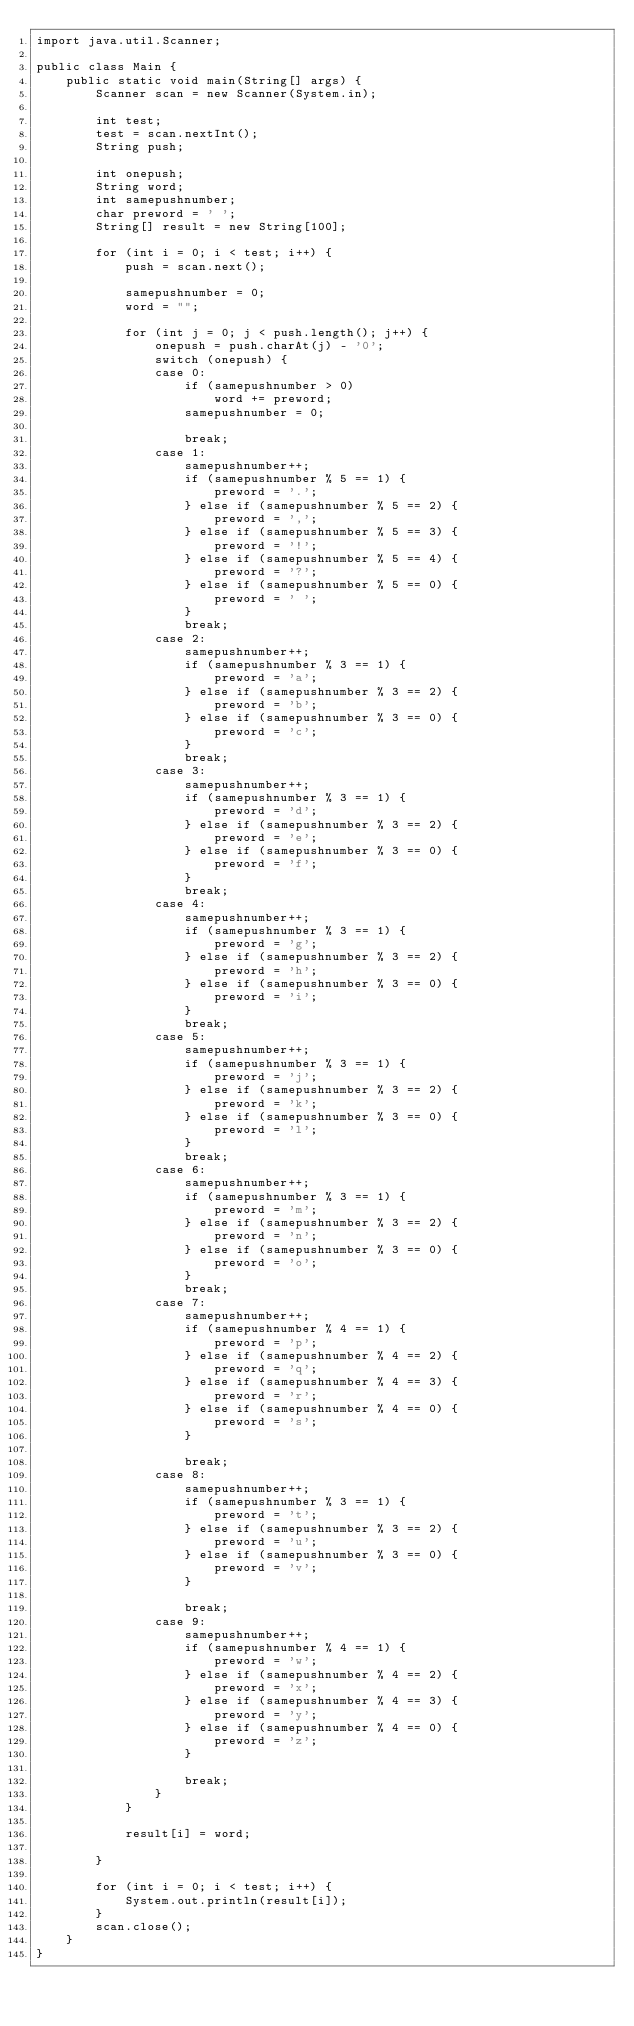<code> <loc_0><loc_0><loc_500><loc_500><_Java_>import java.util.Scanner;

public class Main {
	public static void main(String[] args) {
		Scanner scan = new Scanner(System.in);

		int test;
		test = scan.nextInt();
		String push;

		int onepush;
		String word;
		int samepushnumber;
		char preword = ' ';
		String[] result = new String[100];

		for (int i = 0; i < test; i++) {
			push = scan.next();

			samepushnumber = 0;
			word = "";

			for (int j = 0; j < push.length(); j++) {
				onepush = push.charAt(j) - '0';
				switch (onepush) {
				case 0:
					if (samepushnumber > 0)
						word += preword;
					samepushnumber = 0;

					break;
				case 1:
					samepushnumber++;
					if (samepushnumber % 5 == 1) {
						preword = '.';
					} else if (samepushnumber % 5 == 2) {
						preword = ',';
					} else if (samepushnumber % 5 == 3) {
						preword = '!';
					} else if (samepushnumber % 5 == 4) {
						preword = '?';
					} else if (samepushnumber % 5 == 0) {
						preword = ' ';
					}
					break;
				case 2:
					samepushnumber++;
					if (samepushnumber % 3 == 1) {
						preword = 'a';
					} else if (samepushnumber % 3 == 2) {
						preword = 'b';
					} else if (samepushnumber % 3 == 0) {
						preword = 'c';
					}
					break;
				case 3:
					samepushnumber++;
					if (samepushnumber % 3 == 1) {
						preword = 'd';
					} else if (samepushnumber % 3 == 2) {
						preword = 'e';
					} else if (samepushnumber % 3 == 0) {
						preword = 'f';
					}
					break;
				case 4:
					samepushnumber++;
					if (samepushnumber % 3 == 1) {
						preword = 'g';
					} else if (samepushnumber % 3 == 2) {
						preword = 'h';
					} else if (samepushnumber % 3 == 0) {
						preword = 'i';
					}
					break;
				case 5:
					samepushnumber++;
					if (samepushnumber % 3 == 1) {
						preword = 'j';
					} else if (samepushnumber % 3 == 2) {
						preword = 'k';
					} else if (samepushnumber % 3 == 0) {
						preword = 'l';
					}
					break;
				case 6:
					samepushnumber++;
					if (samepushnumber % 3 == 1) {
						preword = 'm';
					} else if (samepushnumber % 3 == 2) {
						preword = 'n';
					} else if (samepushnumber % 3 == 0) {
						preword = 'o';
					}
					break;
				case 7:
					samepushnumber++;
					if (samepushnumber % 4 == 1) {
						preword = 'p';
					} else if (samepushnumber % 4 == 2) {
						preword = 'q';
					} else if (samepushnumber % 4 == 3) {
						preword = 'r';
					} else if (samepushnumber % 4 == 0) {
						preword = 's';
					}

					break;
				case 8:
					samepushnumber++;
					if (samepushnumber % 3 == 1) {
						preword = 't';
					} else if (samepushnumber % 3 == 2) {
						preword = 'u';
					} else if (samepushnumber % 3 == 0) {
						preword = 'v';
					}

					break;
				case 9:
					samepushnumber++;
					if (samepushnumber % 4 == 1) {
						preword = 'w';
					} else if (samepushnumber % 4 == 2) {
						preword = 'x';
					} else if (samepushnumber % 4 == 3) {
						preword = 'y';
					} else if (samepushnumber % 4 == 0) {
						preword = 'z';
					}

					break;
				}
			}

			result[i] = word;

		}

		for (int i = 0; i < test; i++) {
			System.out.println(result[i]);
		}
		scan.close();
	}
}</code> 